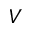<formula> <loc_0><loc_0><loc_500><loc_500>V</formula> 